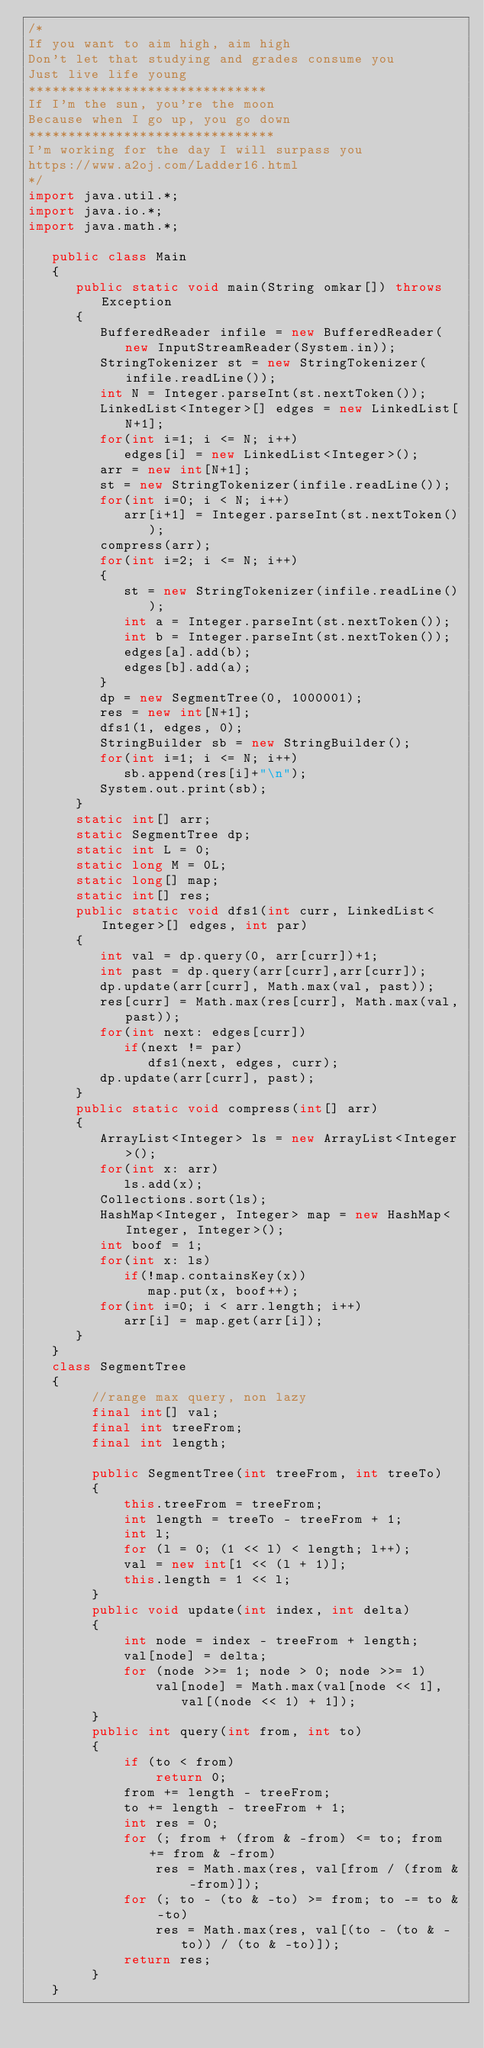<code> <loc_0><loc_0><loc_500><loc_500><_Java_>/*
If you want to aim high, aim high
Don't let that studying and grades consume you
Just live life young
******************************
If I'm the sun, you're the moon
Because when I go up, you go down
*******************************
I'm working for the day I will surpass you
https://www.a2oj.com/Ladder16.html
*/
import java.util.*;
import java.io.*;
import java.math.*;

   public class Main
   {
      public static void main(String omkar[]) throws Exception
      {
         BufferedReader infile = new BufferedReader(new InputStreamReader(System.in));  
         StringTokenizer st = new StringTokenizer(infile.readLine());
         int N = Integer.parseInt(st.nextToken());
         LinkedList<Integer>[] edges = new LinkedList[N+1];
         for(int i=1; i <= N; i++)
            edges[i] = new LinkedList<Integer>();
         arr = new int[N+1];
         st = new StringTokenizer(infile.readLine());
         for(int i=0; i < N; i++)
            arr[i+1] = Integer.parseInt(st.nextToken());
         compress(arr);
         for(int i=2; i <= N; i++)
         {
            st = new StringTokenizer(infile.readLine());
            int a = Integer.parseInt(st.nextToken());
            int b = Integer.parseInt(st.nextToken());
            edges[a].add(b);
            edges[b].add(a);
         }
         dp = new SegmentTree(0, 1000001);
         res = new int[N+1];
         dfs1(1, edges, 0);
         StringBuilder sb = new StringBuilder();
         for(int i=1; i <= N; i++)
            sb.append(res[i]+"\n");
         System.out.print(sb);
      }
      static int[] arr;
      static SegmentTree dp;
      static int L = 0;
      static long M = 0L;
      static long[] map;
      static int[] res;
      public static void dfs1(int curr, LinkedList<Integer>[] edges, int par)
      {
         int val = dp.query(0, arr[curr])+1;
         int past = dp.query(arr[curr],arr[curr]);
         dp.update(arr[curr], Math.max(val, past));
         res[curr] = Math.max(res[curr], Math.max(val,past));
         for(int next: edges[curr])
            if(next != par)
               dfs1(next, edges, curr);
         dp.update(arr[curr], past);
      }
      public static void compress(int[] arr)
      {
         ArrayList<Integer> ls = new ArrayList<Integer>();
         for(int x: arr)
            ls.add(x);
         Collections.sort(ls);
         HashMap<Integer, Integer> map = new HashMap<Integer, Integer>();
         int boof = 1;
         for(int x: ls)
            if(!map.containsKey(x))
               map.put(x, boof++);
         for(int i=0; i < arr.length; i++)
            arr[i] = map.get(arr[i]);
      }
   }
   class SegmentTree 
   {
        //range max query, non lazy
        final int[] val;
        final int treeFrom;
        final int length;
    
        public SegmentTree(int treeFrom, int treeTo) 
        {
            this.treeFrom = treeFrom;
            int length = treeTo - treeFrom + 1;
            int l;
            for (l = 0; (1 << l) < length; l++);
            val = new int[1 << (l + 1)];
            this.length = 1 << l;
        }
        public void update(int index, int delta) 
        {
            int node = index - treeFrom + length;
            val[node] = delta;
            for (node >>= 1; node > 0; node >>= 1) 
                val[node] = Math.max(val[node << 1], val[(node << 1) + 1]);
        }
        public int query(int from, int to) 
        {
            if (to < from)
                return 0;
            from += length - treeFrom;
            to += length - treeFrom + 1;
            int res = 0;
            for (; from + (from & -from) <= to; from += from & -from) 
                res = Math.max(res, val[from / (from & -from)]);
            for (; to - (to & -to) >= from; to -= to & -to)
                res = Math.max(res, val[(to - (to & -to)) / (to & -to)]);
            return res;
        }
   }</code> 